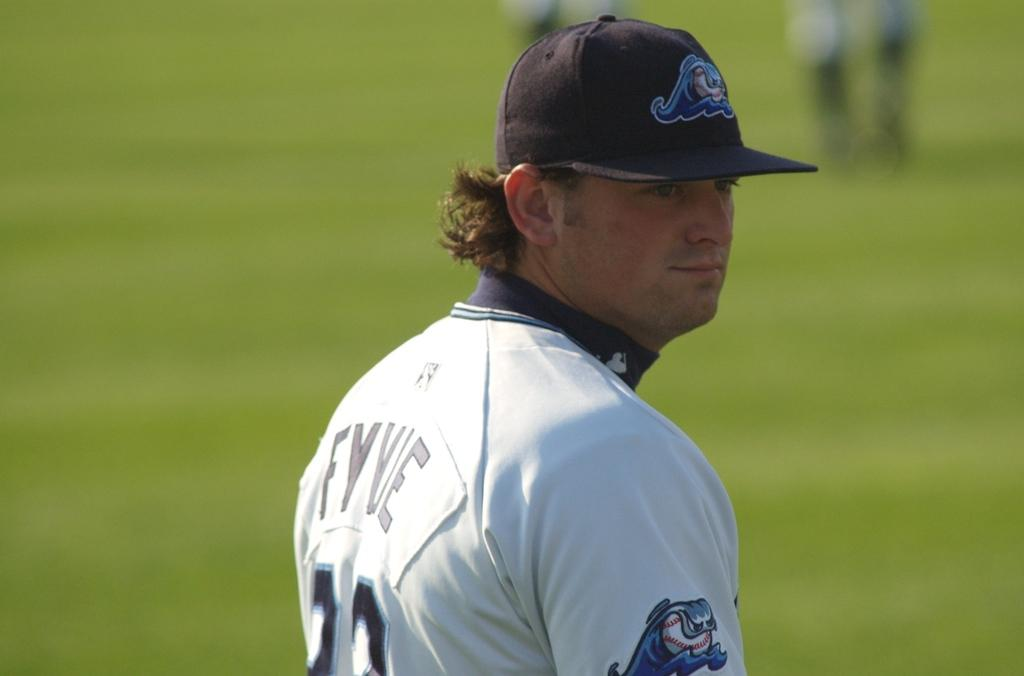Who is present in the image? There is a person in the image. What is the person wearing on their upper body? The person is wearing a white t-shirt. What type of headwear is the person wearing? The person is wearing a cap. Can you describe the background of the image? The background of the image is blurred. How many people are visible in the image? There are people visible in the image. How does the person in the image express their feeling of excitement? The image does not show the person expressing any feelings or emotions, so it cannot be determined from the image. 